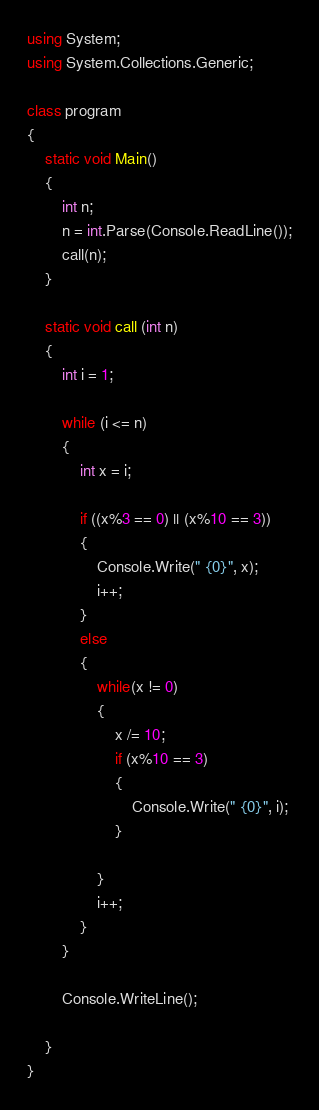<code> <loc_0><loc_0><loc_500><loc_500><_C#_>using System;
using System.Collections.Generic;

class program
{
    static void Main()
    {
        int n;
        n = int.Parse(Console.ReadLine());
        call(n);
    }

    static void call (int n)
    {
        int i = 1;

        while (i <= n)
        {
            int x = i;

            if ((x%3 == 0) || (x%10 == 3))
            {
                Console.Write(" {0}", x);
                i++;
            }
            else
            {
                while(x != 0)
                {
                    x /= 10;
                    if (x%10 == 3)
                    {
                        Console.Write(" {0}", i);
                    }
                    
                }
                i++;
            }
        }

        Console.WriteLine();

    }
}</code> 